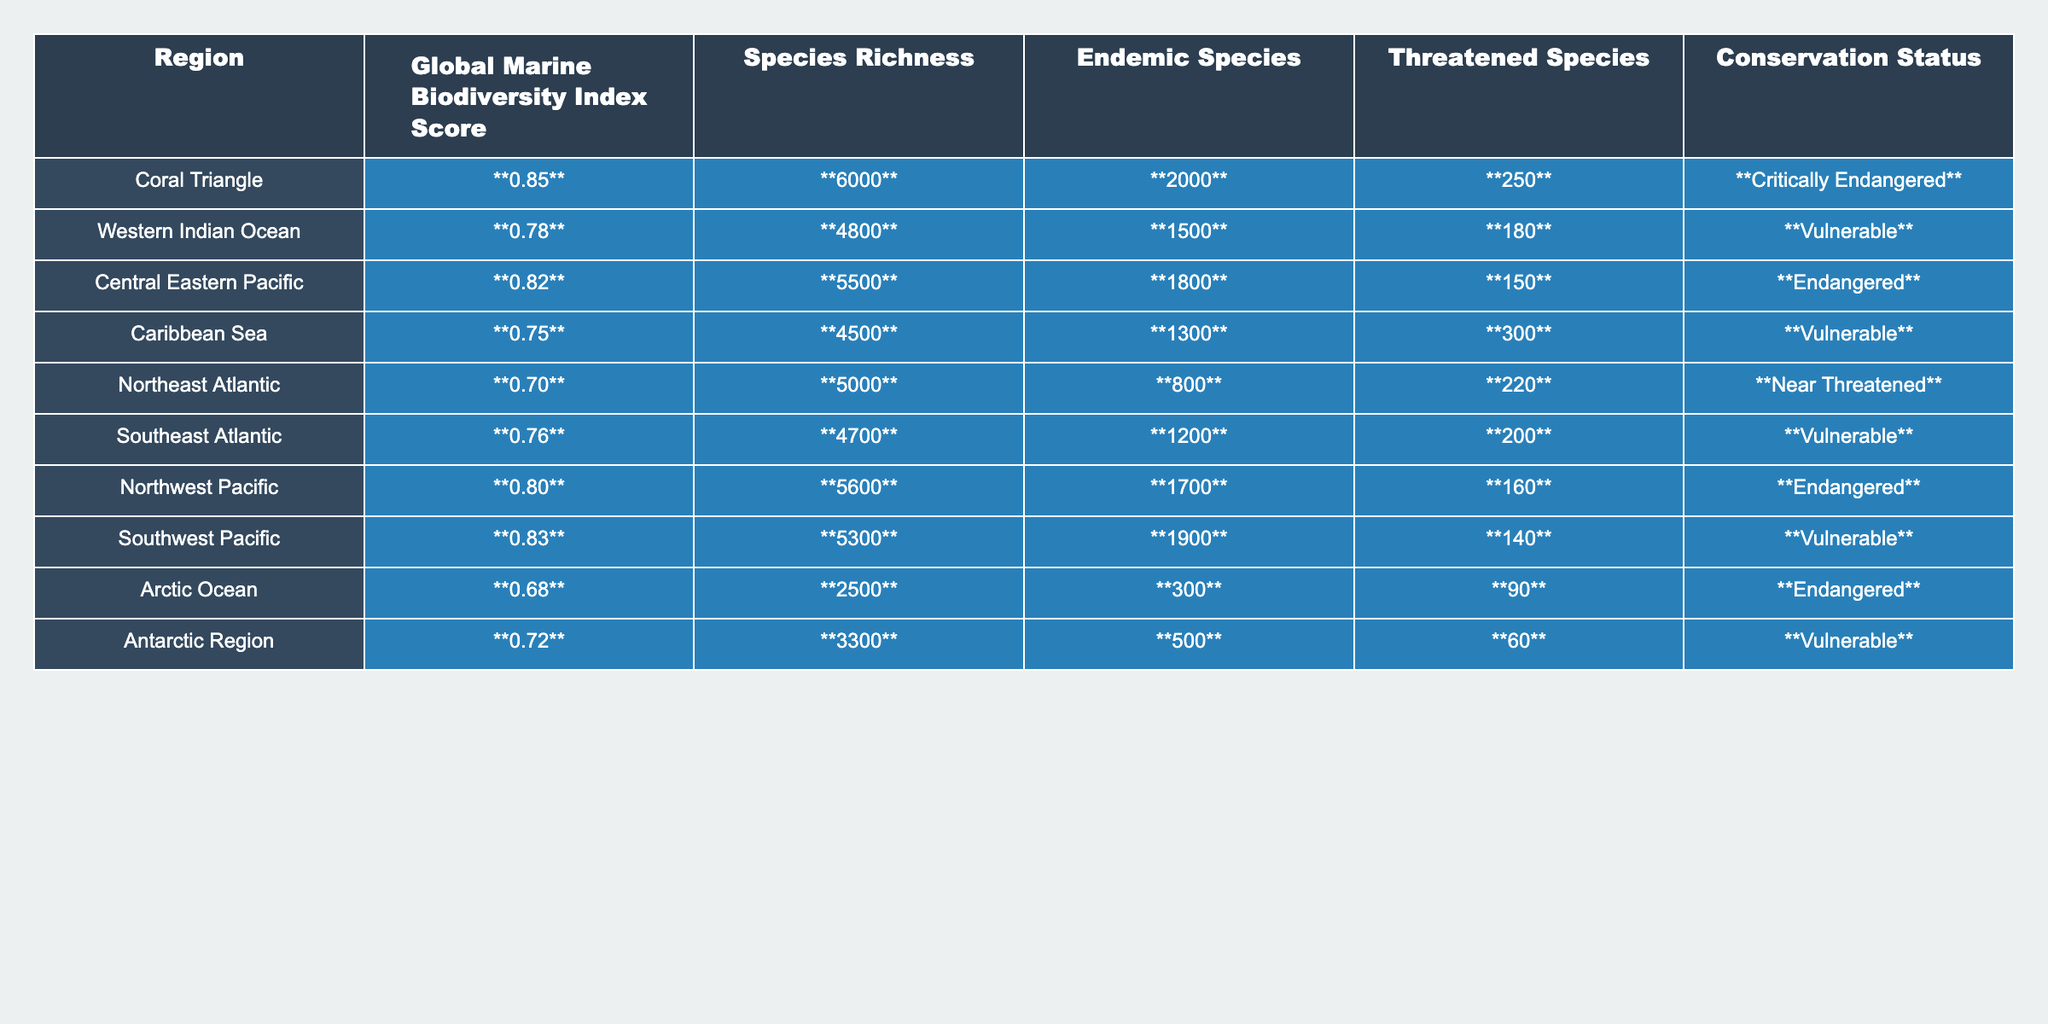What is the Global Marine Biodiversity Index Score for the Coral Triangle? The table lists the Global Marine Biodiversity Index Score for the Coral Triangle as **0.85**.
Answer: 0.85 How many endemic species are found in the Southwest Pacific? According to the table, the number of endemic species in the Southwest Pacific is **1900**.
Answer: 1900 Which region has the highest number of threatened species? By examining the table, the Caribbean Sea has the highest number of threatened species at **300**.
Answer: Caribbean Sea What is the average Global Marine Biodiversity Index Score across all regions? The scores are 0.85, 0.78, 0.82, 0.75, 0.70, 0.76, 0.80, 0.83, 0.68, and 0.72. Summing these gives 0.85 + 0.78 + 0.82 + 0.75 + 0.70 + 0.76 + 0.80 + 0.83 + 0.68 + 0.72 = 7.66. Dividing by 10 (the number of regions) gives an average of 0.766.
Answer: 0.766 Is the Arctic Ocean classified as critically endangered? The table indicates that the Arctic Ocean has a conservation status of **Endangered**, not critically endangered.
Answer: No Which region has the lowest species richness? Looking at the table, the Arctic Ocean has the lowest species richness with **2500** species.
Answer: Arctic Ocean How many regions have a Global Marine Biodiversity Index Score greater than 0.80? The regions with scores greater than 0.80 are Coral Triangle (0.85), Central Eastern Pacific (0.82), Northwest Pacific (0.80), Southwest Pacific (0.83). Counting them gives **four** regions.
Answer: 4 Which region is classified as vulnerable but has the highest species richness? The Southeast Atlantic has a conservation status of **Vulnerable** and a species richness of **4700**, which is the highest among vulnerable regions.
Answer: Southeast Atlantic What is the total number of endemic species across all regions? The endemic species counts are 2000, 1500, 1800, 1300, 800, 1200, 1700, 1900, 300, and 500. Summing these gives 2000 + 1500 + 1800 + 1300 + 800 + 1200 + 1700 + 1900 + 300 + 500 =  12100.
Answer: 12100 True or False: The Caribbean Sea is at a critically endangered conservation status. The table categorizes the Caribbean Sea as **Vulnerable**, not critically endangered, making this statement **False**.
Answer: False 